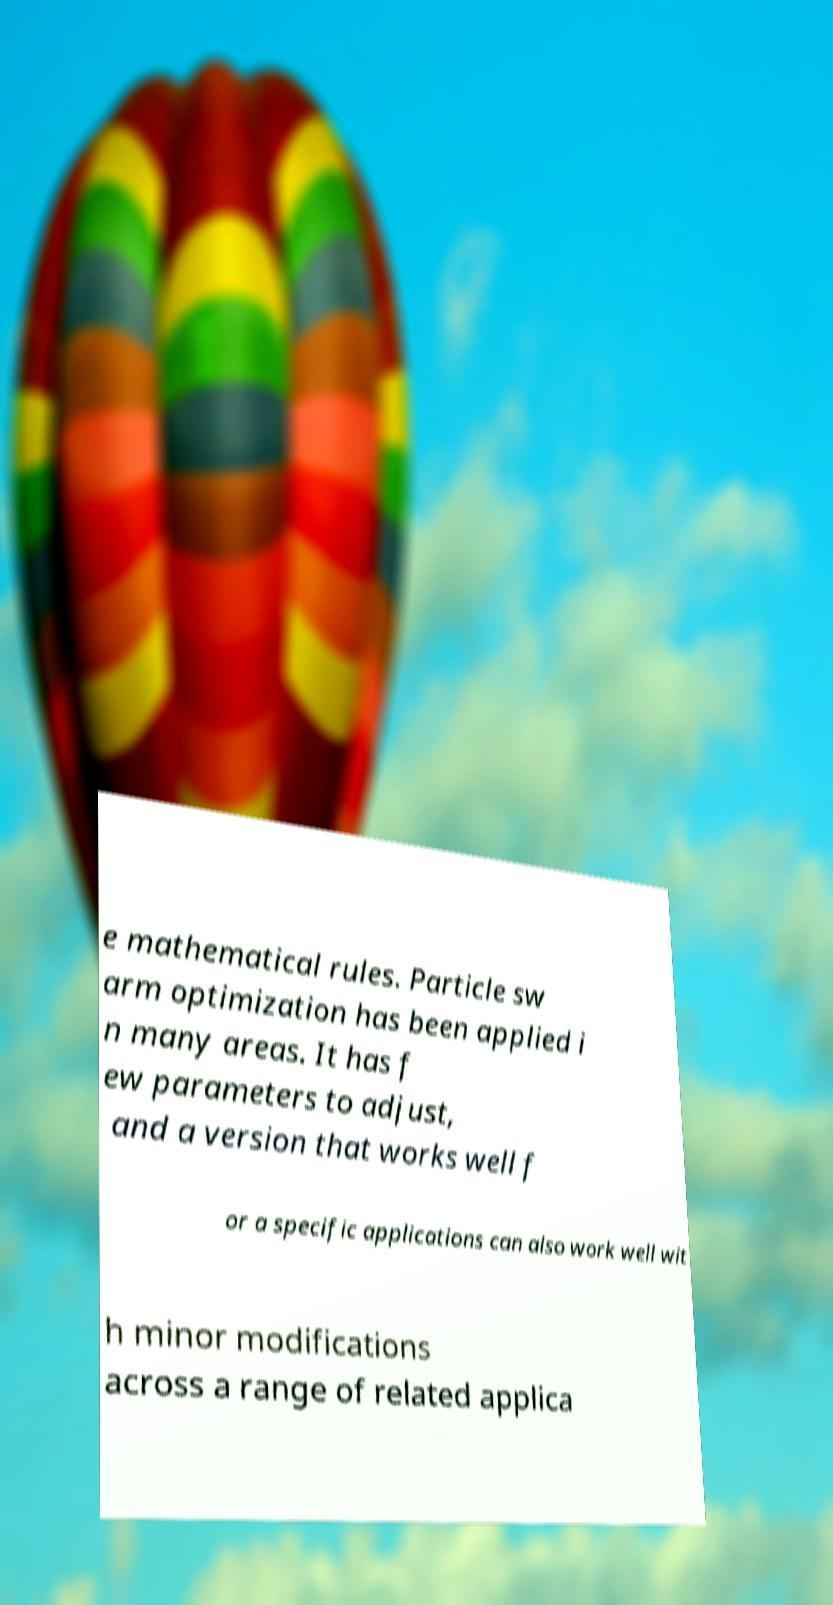Please identify and transcribe the text found in this image. e mathematical rules. Particle sw arm optimization has been applied i n many areas. It has f ew parameters to adjust, and a version that works well f or a specific applications can also work well wit h minor modifications across a range of related applica 